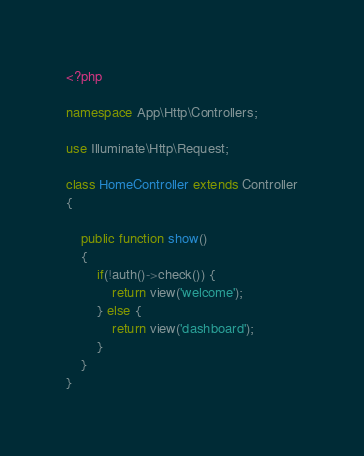Convert code to text. <code><loc_0><loc_0><loc_500><loc_500><_PHP_><?php

namespace App\Http\Controllers;

use Illuminate\Http\Request;

class HomeController extends Controller
{

    public function show()
    {
        if(!auth()->check()) {
            return view('welcome');
        } else {
            return view('dashboard');
        }
    }
}</code> 